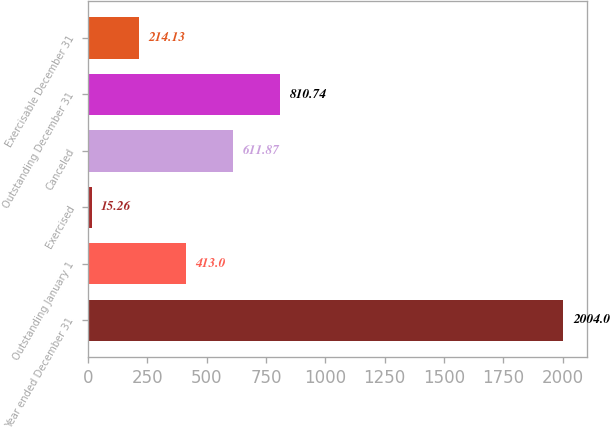<chart> <loc_0><loc_0><loc_500><loc_500><bar_chart><fcel>Year ended December 31<fcel>Outstanding January 1<fcel>Exercised<fcel>Canceled<fcel>Outstanding December 31<fcel>Exercisable December 31<nl><fcel>2004<fcel>413<fcel>15.26<fcel>611.87<fcel>810.74<fcel>214.13<nl></chart> 